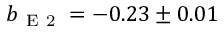Convert formula to latex. <formula><loc_0><loc_0><loc_500><loc_500>b _ { E 2 } = - 0 . 2 3 \pm 0 . 0 1</formula> 